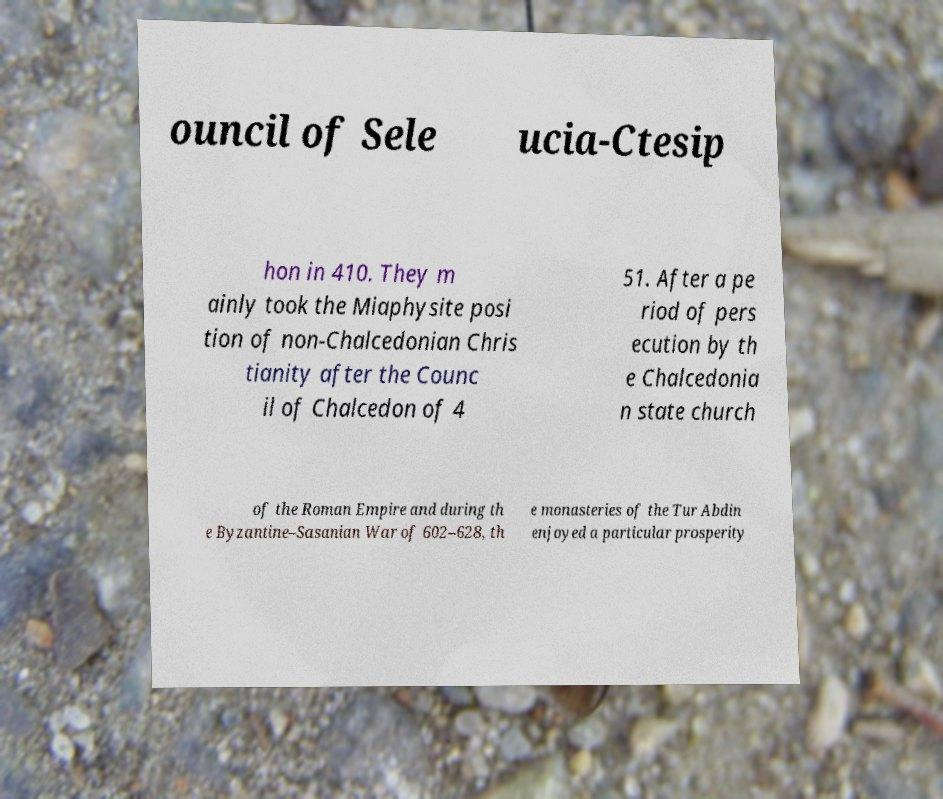Could you assist in decoding the text presented in this image and type it out clearly? ouncil of Sele ucia-Ctesip hon in 410. They m ainly took the Miaphysite posi tion of non-Chalcedonian Chris tianity after the Counc il of Chalcedon of 4 51. After a pe riod of pers ecution by th e Chalcedonia n state church of the Roman Empire and during th e Byzantine–Sasanian War of 602–628, th e monasteries of the Tur Abdin enjoyed a particular prosperity 